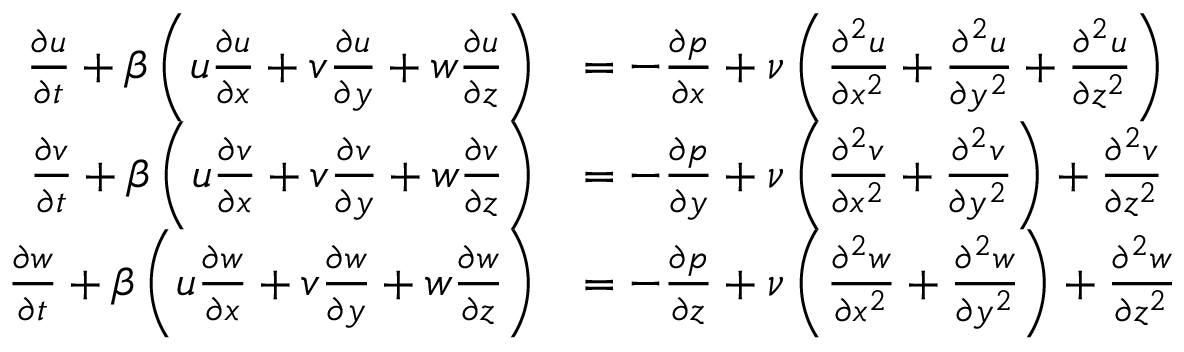<formula> <loc_0><loc_0><loc_500><loc_500>\begin{array} { r l } { \frac { \partial u } { \partial t } + \beta \left ( u \frac { \partial u } { \partial x } + v \frac { \partial u } { \partial y } + w \frac { \partial u } { \partial z } \right ) } & { = - \frac { \partial p } { \partial x } + \nu \left ( \frac { \partial ^ { 2 } u } { \partial x ^ { 2 } } + \frac { \partial ^ { 2 } u } { \partial y ^ { 2 } } + \frac { \partial ^ { 2 } u } { \partial z ^ { 2 } } \right ) } \\ { \frac { \partial v } { \partial t } + \beta \left ( u \frac { \partial v } { \partial x } + v \frac { \partial v } { \partial y } + w \frac { \partial v } { \partial z } \right ) } & { = - \frac { \partial p } { \partial y } + \nu \left ( \frac { \partial ^ { 2 } v } { \partial x ^ { 2 } } + \frac { \partial ^ { 2 } v } { \partial y ^ { 2 } } \right ) + \frac { \partial ^ { 2 } v } { \partial z ^ { 2 } } } \\ { \frac { \partial w } { \partial t } + \beta \left ( u \frac { \partial w } { \partial x } + v \frac { \partial w } { \partial y } + w \frac { \partial w } { \partial z } \right ) } & { = - \frac { \partial p } { \partial z } + \nu \left ( \frac { \partial ^ { 2 } w } { \partial x ^ { 2 } } + \frac { \partial ^ { 2 } w } { \partial y ^ { 2 } } \right ) + \frac { \partial ^ { 2 } w } { \partial z ^ { 2 } } } \end{array}</formula> 